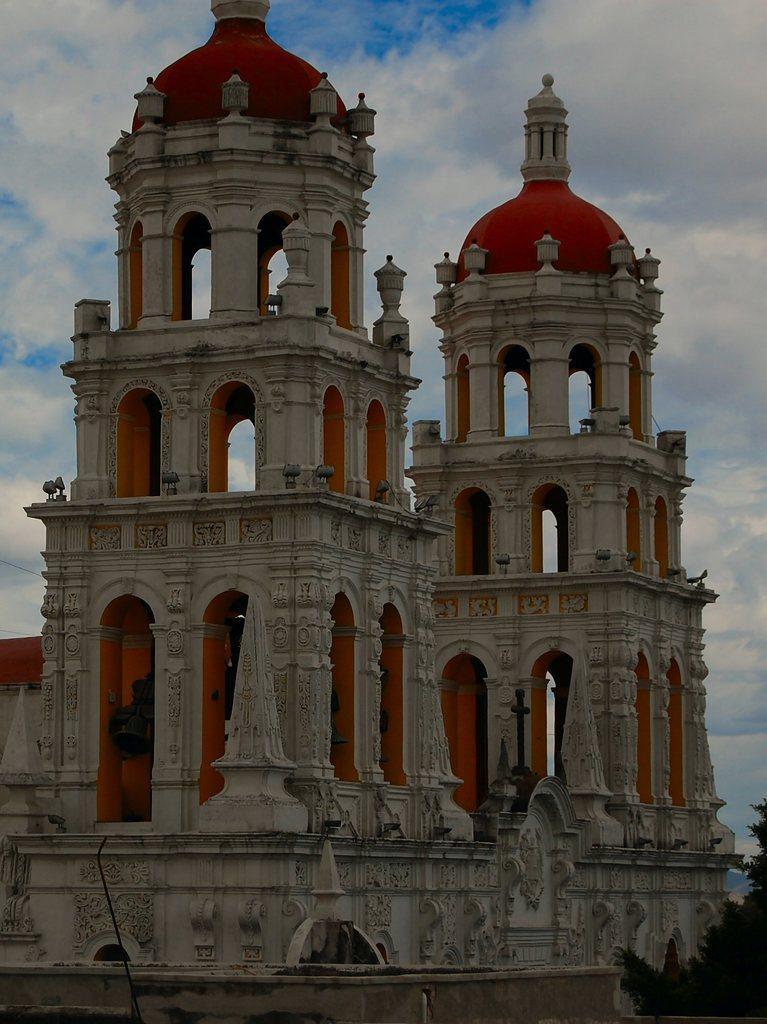Please provide a concise description of this image. In this picture there is a white and orange color two temple towers seen in the front with some arch and dome on the top. Behind there is a sky and clouds. 